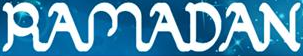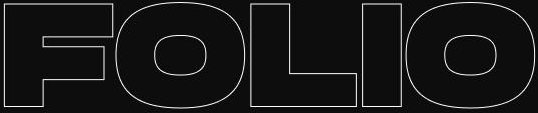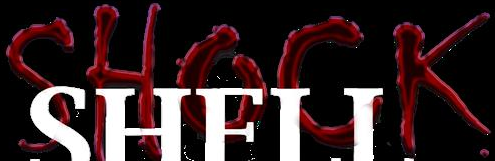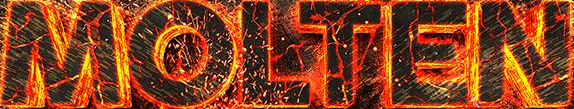Read the text from these images in sequence, separated by a semicolon. RAMADAN; FOLIO; SHOCK; MOLTEN 